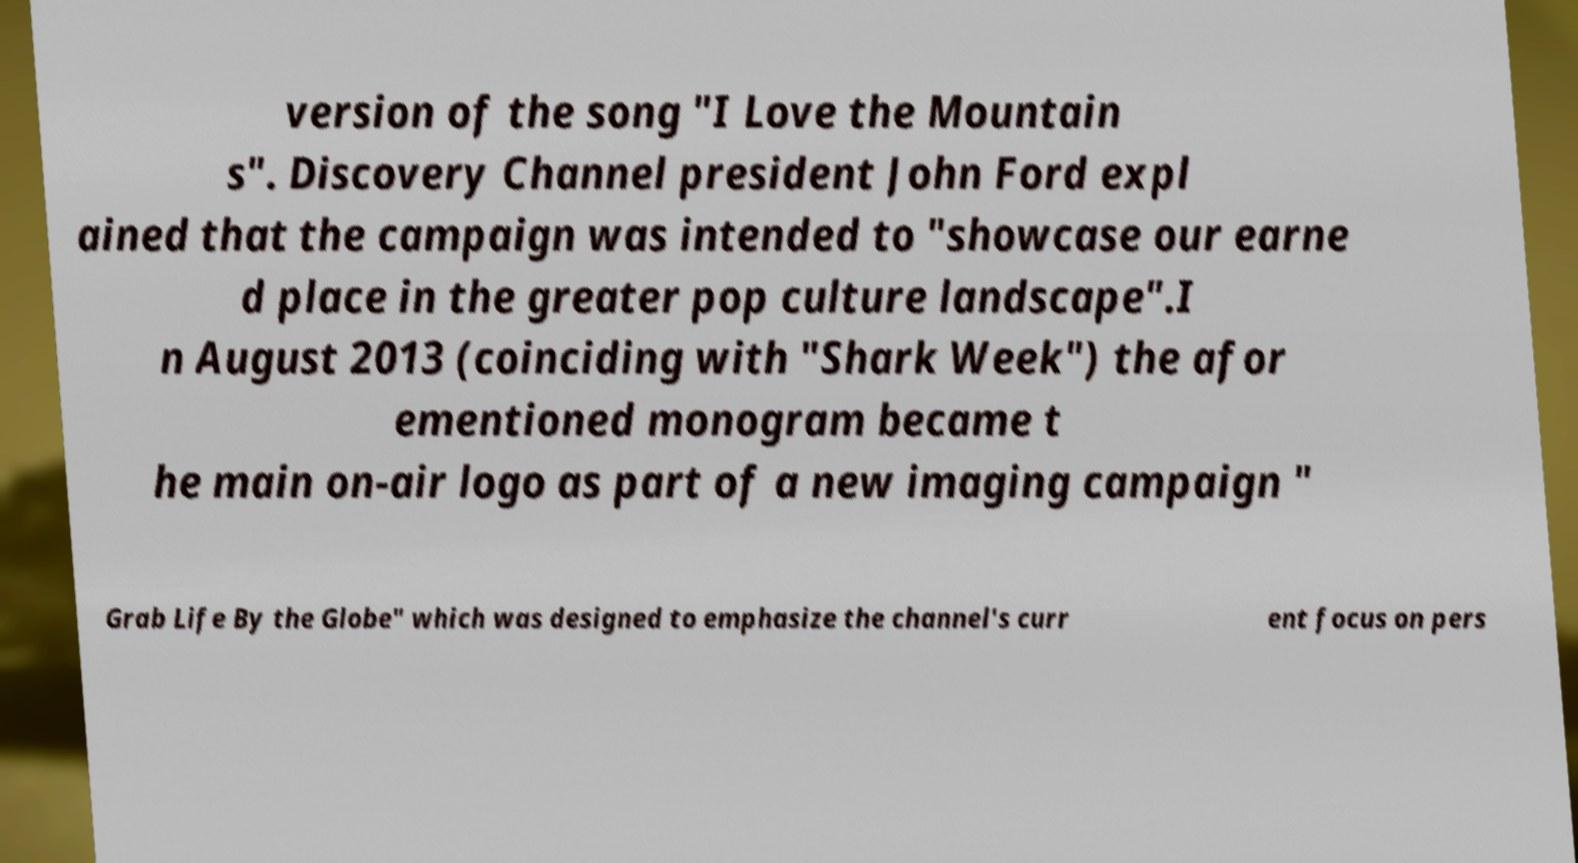Could you extract and type out the text from this image? version of the song "I Love the Mountain s". Discovery Channel president John Ford expl ained that the campaign was intended to "showcase our earne d place in the greater pop culture landscape".I n August 2013 (coinciding with "Shark Week") the afor ementioned monogram became t he main on-air logo as part of a new imaging campaign " Grab Life By the Globe" which was designed to emphasize the channel's curr ent focus on pers 